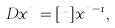<formula> <loc_0><loc_0><loc_500><loc_500>D x ^ { n } = [ n ] x ^ { n - 1 } ,</formula> 